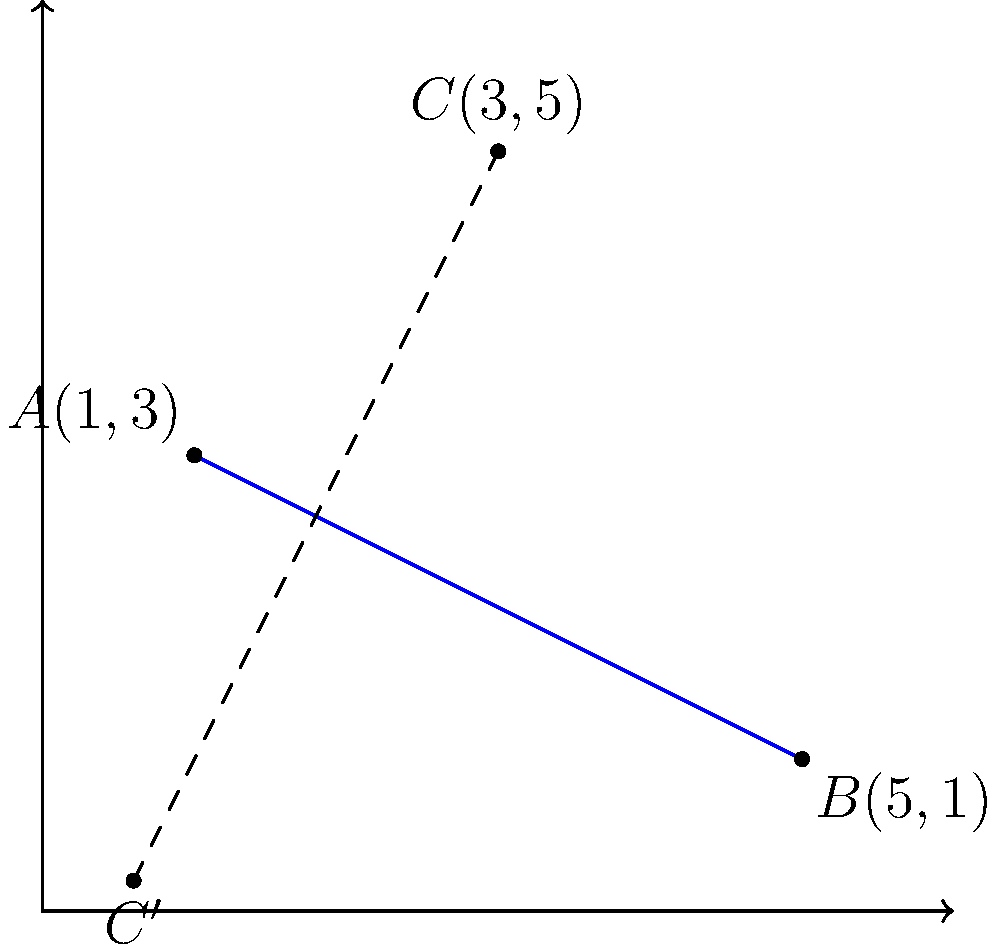An owl is guided by a bat along a straight flight path represented by the line passing through points $A(1,3)$ and $B(5,1)$. The owl's initial position is at point $C(3,5)$. If the owl's position is reflected across its flight path, what are the coordinates of its new position $C'$? To find the coordinates of $C'$, we need to reflect point $C$ across the line $AB$. Let's follow these steps:

1) First, we need to find the equation of line $AB$:
   Slope $m = \frac{1-3}{5-1} = -\frac{1}{2}$
   Using point-slope form: $y - 3 = -\frac{1}{2}(x - 1)$
   Simplifying: $y = -\frac{1}{2}x + \frac{7}{2}$

2) The general formula for reflecting a point $(x,y)$ across the line $ax + by + c = 0$ is:
   $(x', y') = (\frac{(b^2-a^2)x - 2ab y - 2ac}{a^2+b^2}, \frac{-2abx + (a^2-b^2)y - 2bc}{a^2+b^2})$

3) Our line equation $y = -\frac{1}{2}x + \frac{7}{2}$ can be rewritten as:
   $\frac{1}{2}x + y - \frac{7}{2} = 0$
   So, $a = \frac{1}{2}$, $b = 1$, and $c = -\frac{7}{2}$

4) Substituting these values and the coordinates of $C(3,5)$ into the reflection formula:

   $x' = \frac{(1^2-(\frac{1}{2})^2)3 - 2(\frac{1}{2})(1)(5) - 2(\frac{1}{2})(-\frac{7}{2})}{(\frac{1}{2})^2+1^2} = 5$

   $y' = \frac{-2(\frac{1}{2})(1)(3) + ((\frac{1}{2})^2-1^2)5 - 2(1)(-\frac{7}{2})}{(\frac{1}{2})^2+1^2} = 1$

5) Therefore, the coordinates of $C'$ are $(5,1)$.
Answer: $(5,1)$ 